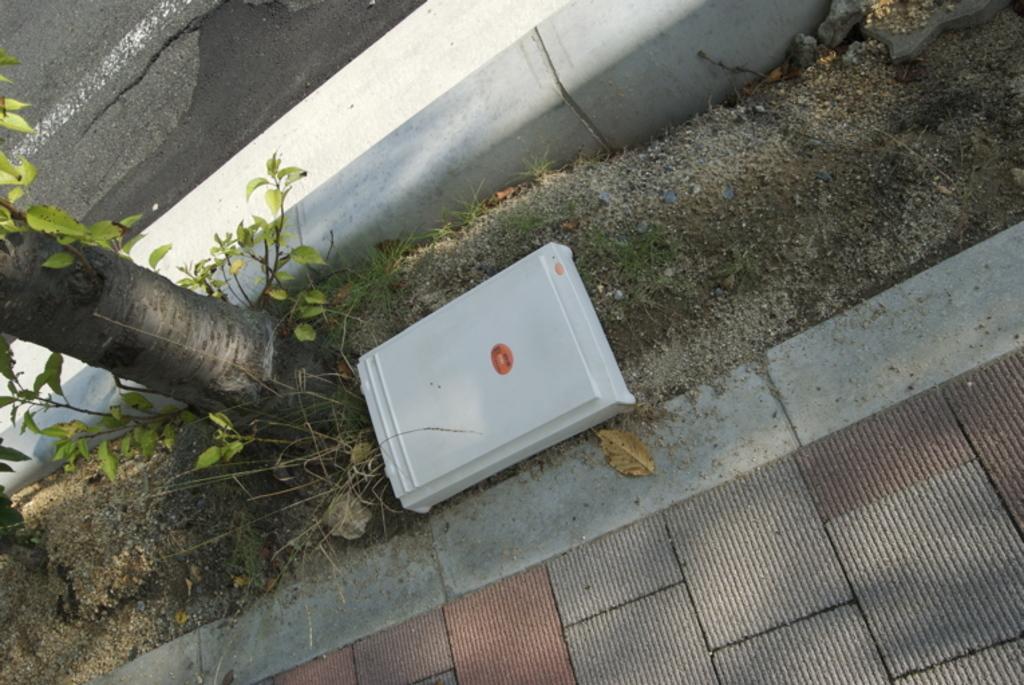Describe this image in one or two sentences. In the center of the image, we can see a box and on the ground and there is a side way and we can see a tree with leaves. At the top, there is road and there is a wall. 